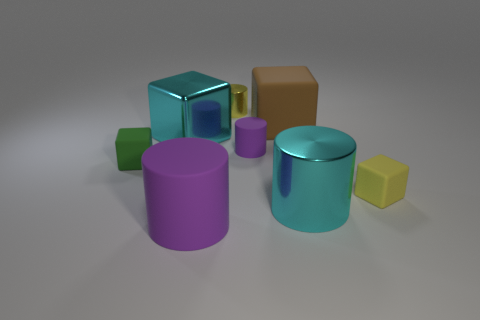Subtract 1 cylinders. How many cylinders are left? 3 Subtract all brown cylinders. Subtract all red cubes. How many cylinders are left? 4 Add 1 small purple things. How many objects exist? 9 Subtract all tiny yellow matte blocks. Subtract all brown rubber cubes. How many objects are left? 6 Add 8 brown blocks. How many brown blocks are left? 9 Add 4 tiny green objects. How many tiny green objects exist? 5 Subtract 1 cyan blocks. How many objects are left? 7 